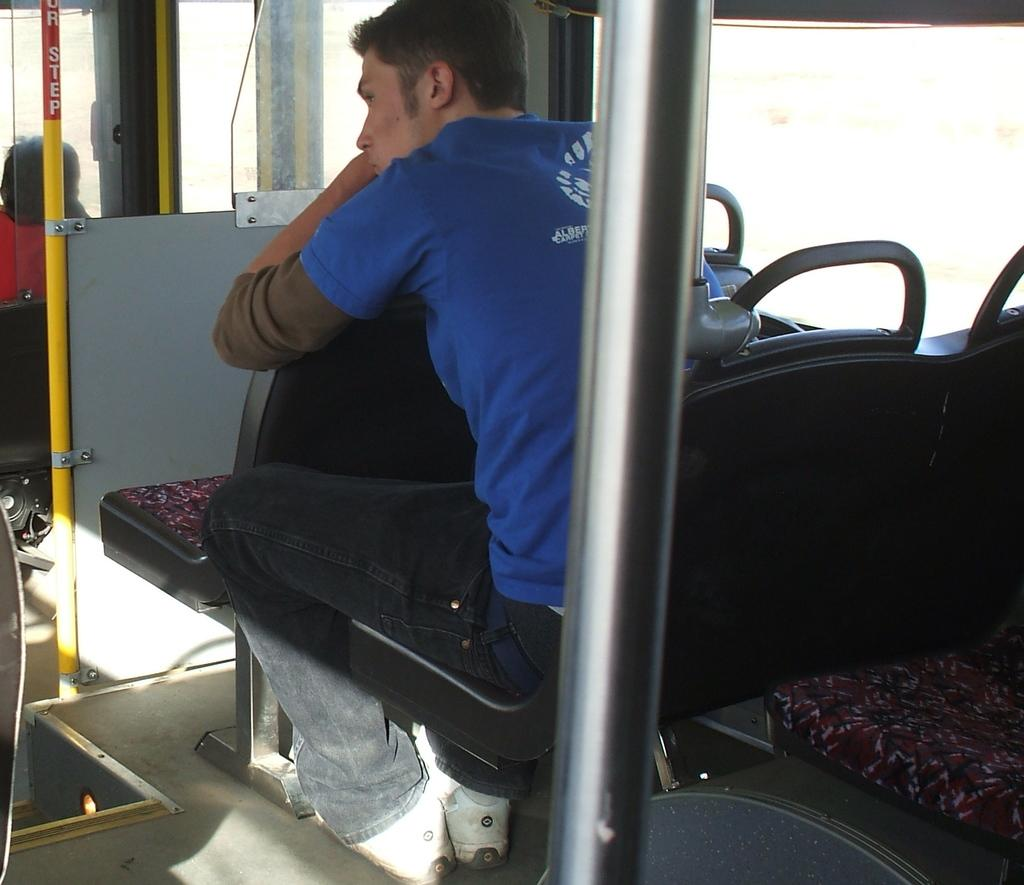What is the person in the image wearing? The person is wearing a blue t-shirt in the image. What is the person in the blue t-shirt doing in the image? The person is sitting in a vehicle. Can you describe the other person in the image? There is another person in the image, but their clothing or actions are not specified. What object can be seen in the image that resembles a long, thin bar? There is a rod visible in the image. What type of seating is available in the image? There is a sitting place in the image. What type of prison can be seen in the image? There is no prison present in the image. How much cream is being used by the person in the blue t-shirt in the image? There is no cream mentioned or visible in the image. 